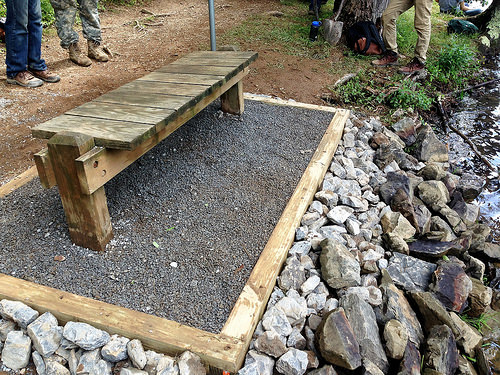<image>
Is there a rock to the left of the bench? No. The rock is not to the left of the bench. From this viewpoint, they have a different horizontal relationship. Is there a bench above the rocks? No. The bench is not positioned above the rocks. The vertical arrangement shows a different relationship. 